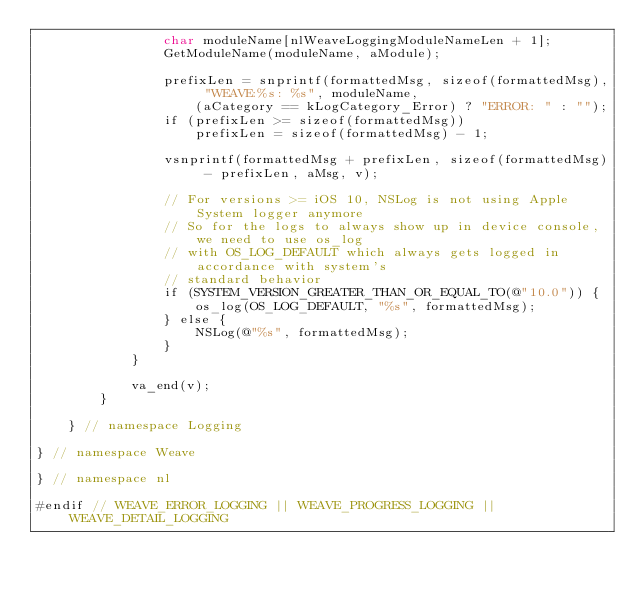<code> <loc_0><loc_0><loc_500><loc_500><_ObjectiveC_>                char moduleName[nlWeaveLoggingModuleNameLen + 1];
                GetModuleName(moduleName, aModule);

                prefixLen = snprintf(formattedMsg, sizeof(formattedMsg), "WEAVE:%s: %s", moduleName,
                    (aCategory == kLogCategory_Error) ? "ERROR: " : "");
                if (prefixLen >= sizeof(formattedMsg))
                    prefixLen = sizeof(formattedMsg) - 1;

                vsnprintf(formattedMsg + prefixLen, sizeof(formattedMsg) - prefixLen, aMsg, v);

                // For versions >= iOS 10, NSLog is not using Apple System logger anymore
                // So for the logs to always show up in device console, we need to use os_log
                // with OS_LOG_DEFAULT which always gets logged in accordance with system's
                // standard behavior
                if (SYSTEM_VERSION_GREATER_THAN_OR_EQUAL_TO(@"10.0")) {
                    os_log(OS_LOG_DEFAULT, "%s", formattedMsg);
                } else {
                    NSLog(@"%s", formattedMsg);
                }
            }

            va_end(v);
        }

    } // namespace Logging

} // namespace Weave

} // namespace nl

#endif // WEAVE_ERROR_LOGGING || WEAVE_PROGRESS_LOGGING || WEAVE_DETAIL_LOGGING
</code> 